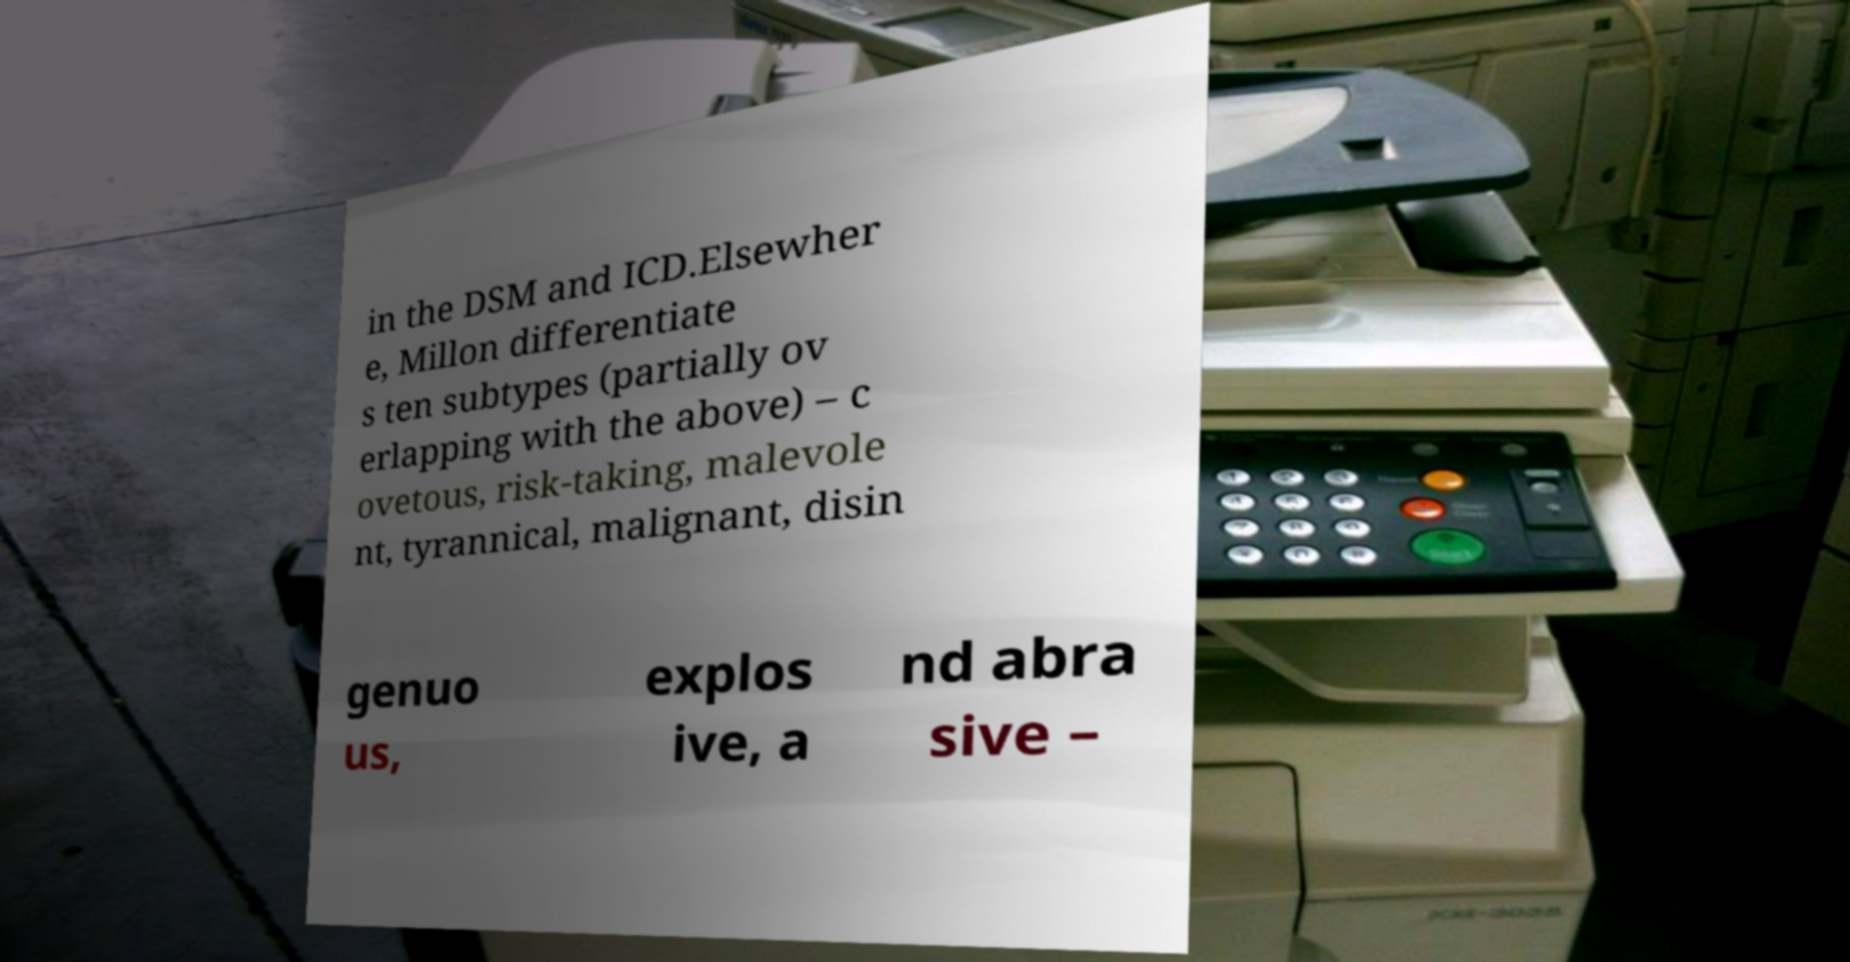Please read and relay the text visible in this image. What does it say? in the DSM and ICD.Elsewher e, Millon differentiate s ten subtypes (partially ov erlapping with the above) – c ovetous, risk-taking, malevole nt, tyrannical, malignant, disin genuo us, explos ive, a nd abra sive – 